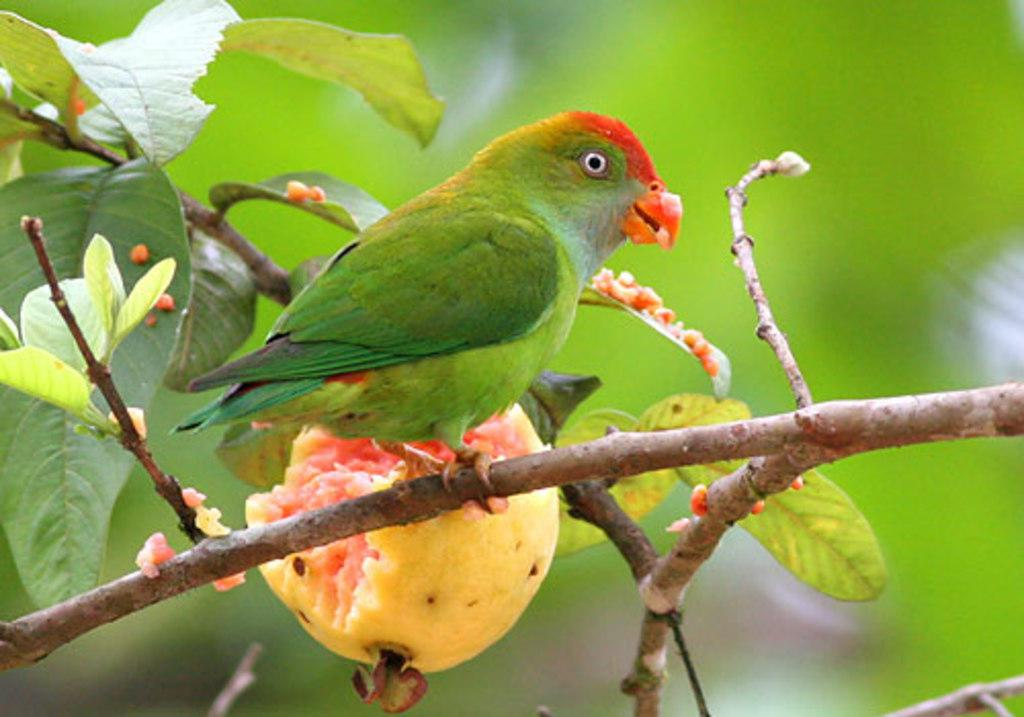What type of animal is in the image? There is a parrot in the image. Where is the parrot located? The parrot is on a tree. What type of fruit is on the plant in the image? There is a guava on the plant. What else can be seen in the image besides the parrot and the guava? Leaves are visible in the image. What type of ice can be seen melting on the parrot's beak in the image? There is no ice present in the image; it features a parrot on a tree with a guava on a plant and leaves visible. 